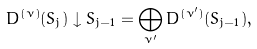Convert formula to latex. <formula><loc_0><loc_0><loc_500><loc_500>D ^ { ( \nu ) } ( S _ { j } ) \downarrow S _ { j - 1 } = \bigoplus _ { \nu ^ { \prime } } D ^ { ( \nu ^ { \prime } ) } ( S _ { j - 1 } ) ,</formula> 